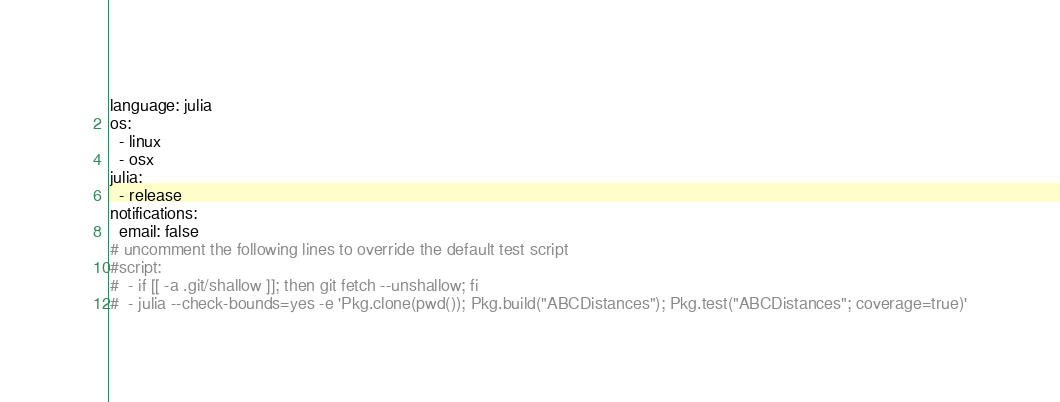Convert code to text. <code><loc_0><loc_0><loc_500><loc_500><_YAML_>language: julia
os:
  - linux
  - osx
julia:
  - release
notifications:
  email: false
# uncomment the following lines to override the default test script
#script:
#  - if [[ -a .git/shallow ]]; then git fetch --unshallow; fi
#  - julia --check-bounds=yes -e 'Pkg.clone(pwd()); Pkg.build("ABCDistances"); Pkg.test("ABCDistances"; coverage=true)'
</code> 